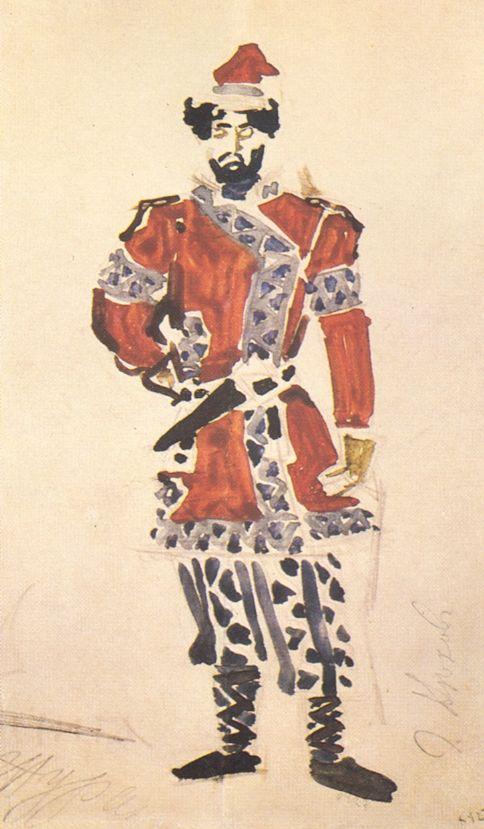Describe the following image. The image depicts a man dressed in a vibrant red and white military uniform, rendered in a loose, impressionistic watercolor style. The man stands confidently, his left hand on his hip and his right holding a sword. His attire, adorned with detailed blue and white patterns, suggests a high-ranking officer, possibly from a historical European army. The red hat, highlighted by a bold white feather, might symbolize valor or rank. This artwork focuses on portraying the dignity and stature of the military figure, using vivid colors and dynamic brushwork to emphasize his presence and role. 